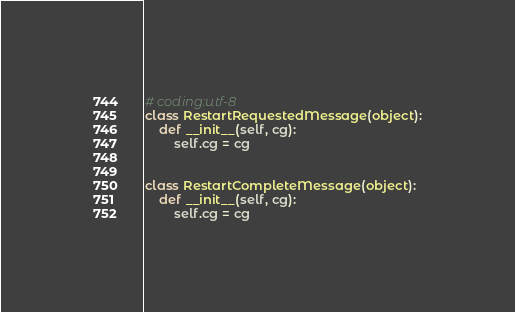Convert code to text. <code><loc_0><loc_0><loc_500><loc_500><_Python_># coding:utf-8
class RestartRequestedMessage(object):
    def __init__(self, cg):
        self.cg = cg


class RestartCompleteMessage(object):
    def __init__(self, cg):
        self.cg = cg
</code> 